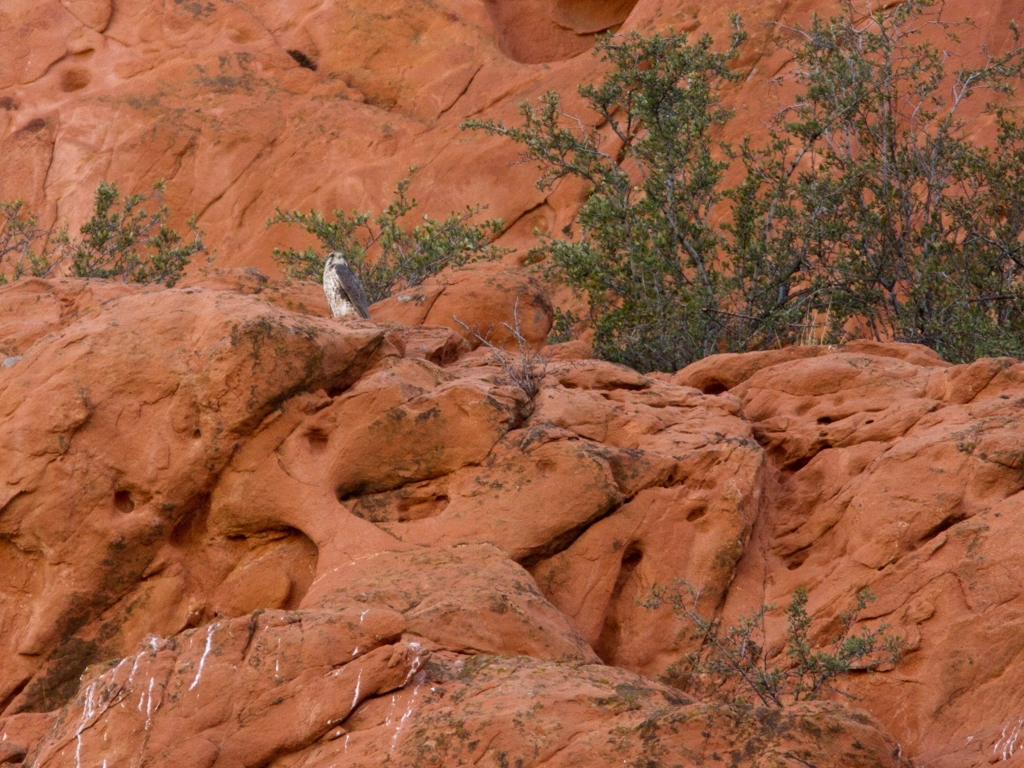Could this location be suitable for hiking or outdoor activities? This area, with its rugged sandstone formations and sparse vegetation, seems quite suitable for outdoor activities such as hiking or rock climbing. However, the terrain appears rough and could present certain challenges, making it important for individuals to be well-prepared and equipped with proper gear. 